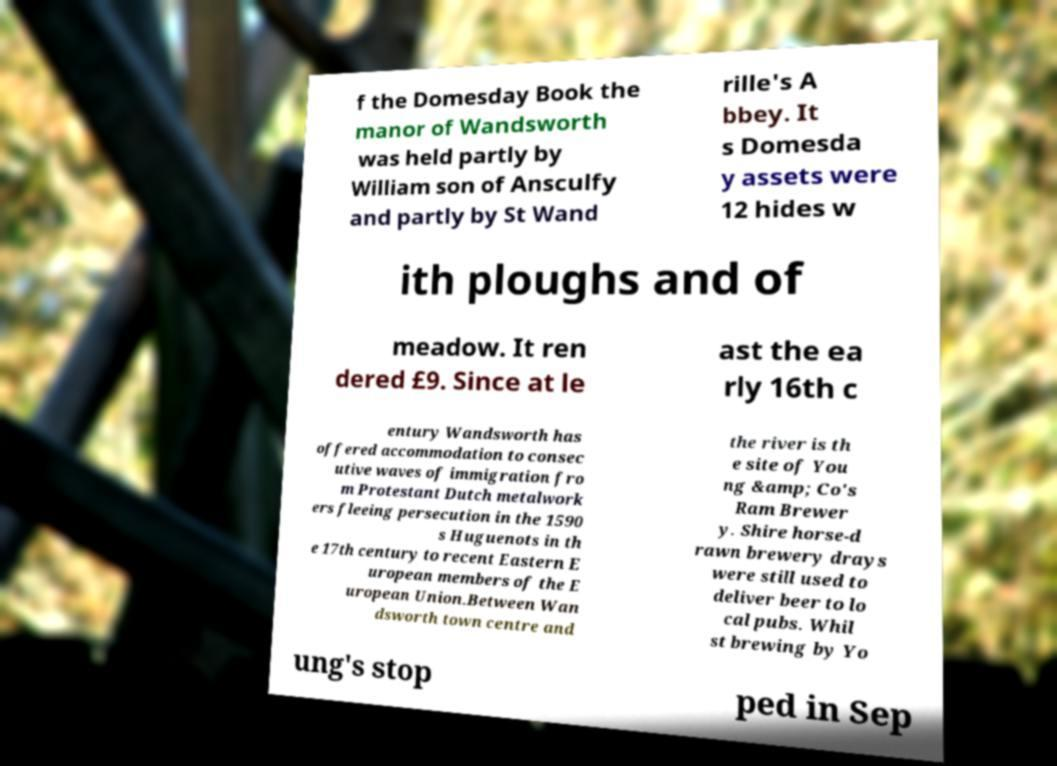Could you assist in decoding the text presented in this image and type it out clearly? f the Domesday Book the manor of Wandsworth was held partly by William son of Ansculfy and partly by St Wand rille's A bbey. It s Domesda y assets were 12 hides w ith ploughs and of meadow. It ren dered £9. Since at le ast the ea rly 16th c entury Wandsworth has offered accommodation to consec utive waves of immigration fro m Protestant Dutch metalwork ers fleeing persecution in the 1590 s Huguenots in th e 17th century to recent Eastern E uropean members of the E uropean Union.Between Wan dsworth town centre and the river is th e site of You ng &amp; Co's Ram Brewer y. Shire horse-d rawn brewery drays were still used to deliver beer to lo cal pubs. Whil st brewing by Yo ung's stop ped in Sep 